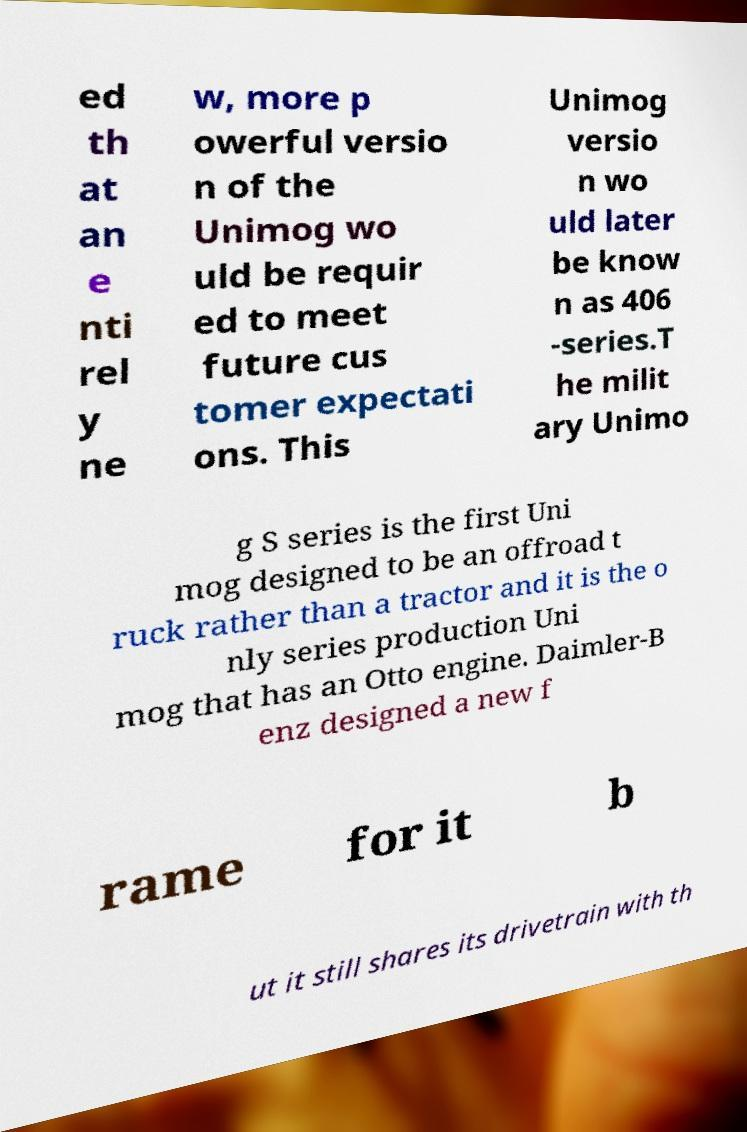What messages or text are displayed in this image? I need them in a readable, typed format. ed th at an e nti rel y ne w, more p owerful versio n of the Unimog wo uld be requir ed to meet future cus tomer expectati ons. This Unimog versio n wo uld later be know n as 406 -series.T he milit ary Unimo g S series is the first Uni mog designed to be an offroad t ruck rather than a tractor and it is the o nly series production Uni mog that has an Otto engine. Daimler-B enz designed a new f rame for it b ut it still shares its drivetrain with th 